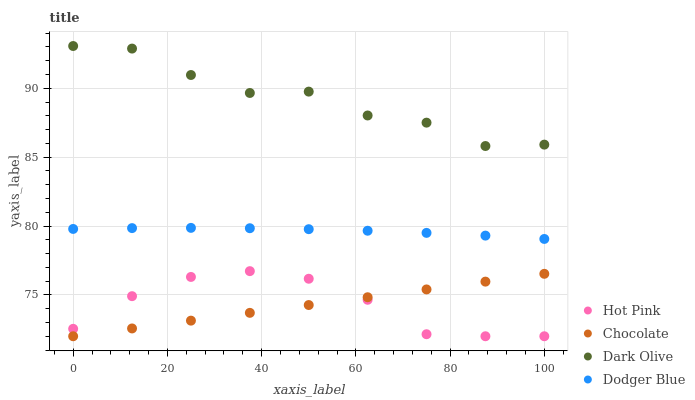Does Chocolate have the minimum area under the curve?
Answer yes or no. Yes. Does Dark Olive have the maximum area under the curve?
Answer yes or no. Yes. Does Hot Pink have the minimum area under the curve?
Answer yes or no. No. Does Hot Pink have the maximum area under the curve?
Answer yes or no. No. Is Chocolate the smoothest?
Answer yes or no. Yes. Is Dark Olive the roughest?
Answer yes or no. Yes. Is Hot Pink the smoothest?
Answer yes or no. No. Is Hot Pink the roughest?
Answer yes or no. No. Does Hot Pink have the lowest value?
Answer yes or no. Yes. Does Dodger Blue have the lowest value?
Answer yes or no. No. Does Dark Olive have the highest value?
Answer yes or no. Yes. Does Hot Pink have the highest value?
Answer yes or no. No. Is Dodger Blue less than Dark Olive?
Answer yes or no. Yes. Is Dark Olive greater than Chocolate?
Answer yes or no. Yes. Does Hot Pink intersect Chocolate?
Answer yes or no. Yes. Is Hot Pink less than Chocolate?
Answer yes or no. No. Is Hot Pink greater than Chocolate?
Answer yes or no. No. Does Dodger Blue intersect Dark Olive?
Answer yes or no. No. 